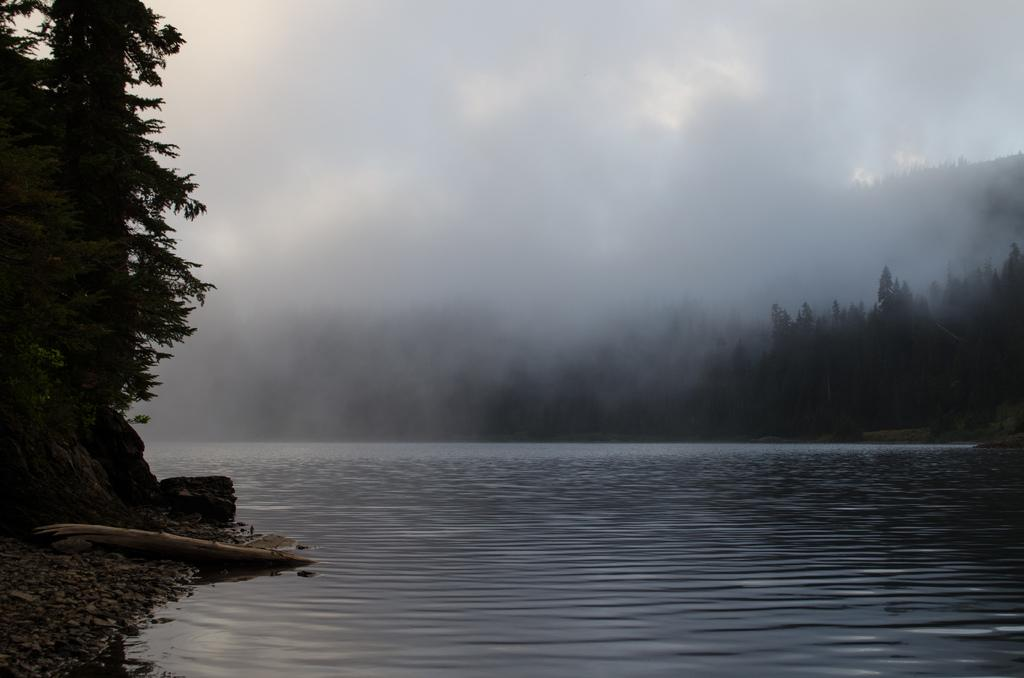What is present at the bottom of the image? There is water at the bottom of the image. What can be seen on the right side of the image? There are trees on the right side of the image. What can be seen on the left side of the image? There are trees on the left side of the image. What type of sidewalk can be seen in the image? There is no sidewalk present in the image. What is the value of the locket in the image? There is no locket present in the image. 